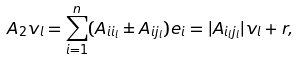<formula> <loc_0><loc_0><loc_500><loc_500>A _ { 2 } v _ { l } = \sum _ { i = 1 } ^ { n } ( A _ { i i _ { l } } \pm A _ { i j _ { l } } ) e _ { i } = | A _ { i _ { l } j _ { l } } | v _ { l } + r ,</formula> 